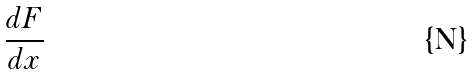<formula> <loc_0><loc_0><loc_500><loc_500>\frac { d F } { d x }</formula> 